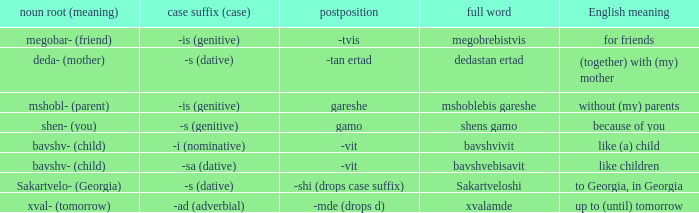What is Postposition, when Noun Root (Meaning) is "mshobl- (parent)"? Gareshe. 